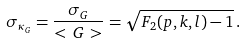<formula> <loc_0><loc_0><loc_500><loc_500>\sigma _ { \kappa _ { G } } = \frac { \sigma _ { G } } { < \, G \, > } = \sqrt { F _ { 2 } ( p , k , l ) - 1 } \, .</formula> 